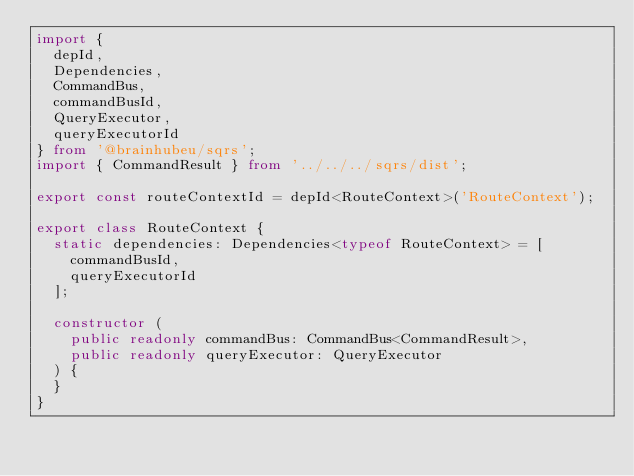Convert code to text. <code><loc_0><loc_0><loc_500><loc_500><_TypeScript_>import {
  depId,
  Dependencies,
  CommandBus,
  commandBusId,
  QueryExecutor,
  queryExecutorId
} from '@brainhubeu/sqrs';
import { CommandResult } from '../../../sqrs/dist';

export const routeContextId = depId<RouteContext>('RouteContext');

export class RouteContext {
  static dependencies: Dependencies<typeof RouteContext> = [
    commandBusId,
    queryExecutorId
  ];

  constructor (
    public readonly commandBus: CommandBus<CommandResult>,
    public readonly queryExecutor: QueryExecutor
  ) {
  }
}
</code> 